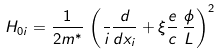Convert formula to latex. <formula><loc_0><loc_0><loc_500><loc_500>H _ { 0 i } = \frac { 1 } { 2 m ^ { * } } \, \left ( \frac { } { i } \frac { d } { d x _ { i } } + \xi \frac { e } { c } \, \frac { \phi } { L } \right ) ^ { 2 }</formula> 